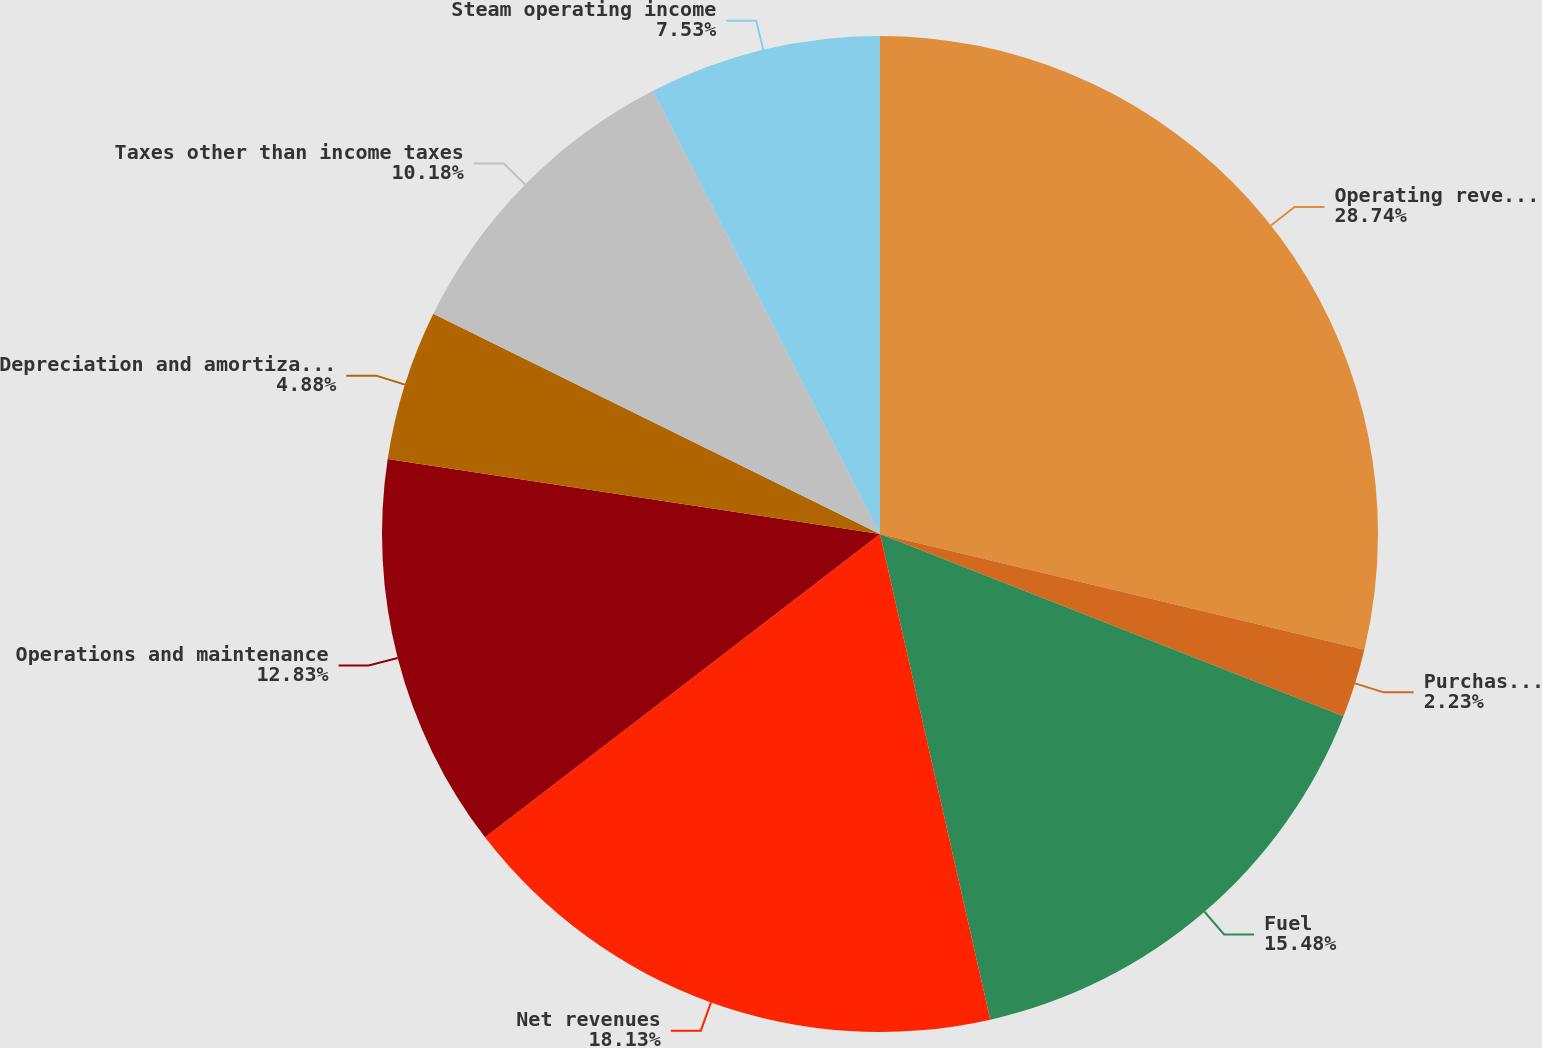<chart> <loc_0><loc_0><loc_500><loc_500><pie_chart><fcel>Operating revenues<fcel>Purchased power<fcel>Fuel<fcel>Net revenues<fcel>Operations and maintenance<fcel>Depreciation and amortization<fcel>Taxes other than income taxes<fcel>Steam operating income<nl><fcel>28.73%<fcel>2.23%<fcel>15.48%<fcel>18.13%<fcel>12.83%<fcel>4.88%<fcel>10.18%<fcel>7.53%<nl></chart> 